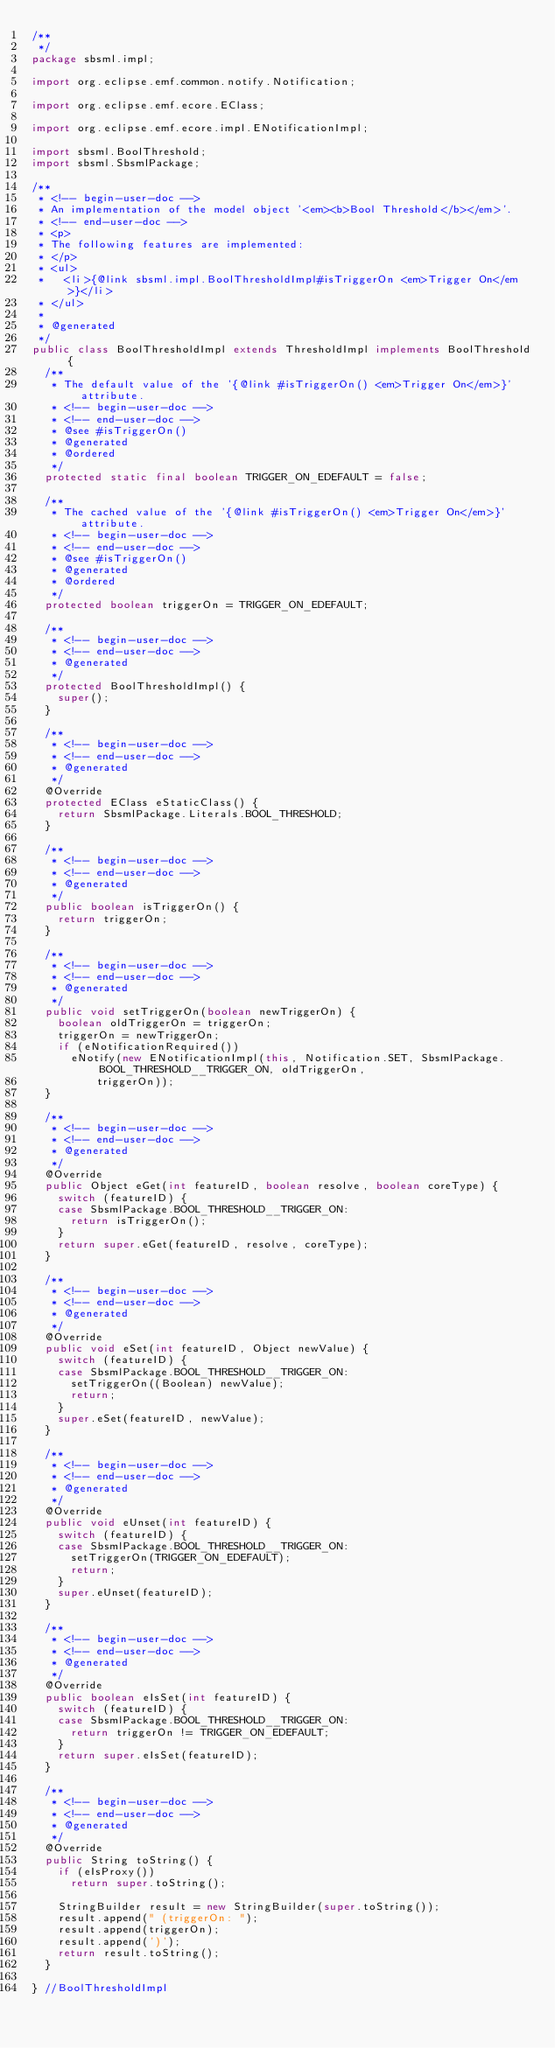Convert code to text. <code><loc_0><loc_0><loc_500><loc_500><_Java_>/**
 */
package sbsml.impl;

import org.eclipse.emf.common.notify.Notification;

import org.eclipse.emf.ecore.EClass;

import org.eclipse.emf.ecore.impl.ENotificationImpl;

import sbsml.BoolThreshold;
import sbsml.SbsmlPackage;

/**
 * <!-- begin-user-doc -->
 * An implementation of the model object '<em><b>Bool Threshold</b></em>'.
 * <!-- end-user-doc -->
 * <p>
 * The following features are implemented:
 * </p>
 * <ul>
 *   <li>{@link sbsml.impl.BoolThresholdImpl#isTriggerOn <em>Trigger On</em>}</li>
 * </ul>
 *
 * @generated
 */
public class BoolThresholdImpl extends ThresholdImpl implements BoolThreshold {
	/**
	 * The default value of the '{@link #isTriggerOn() <em>Trigger On</em>}' attribute.
	 * <!-- begin-user-doc -->
	 * <!-- end-user-doc -->
	 * @see #isTriggerOn()
	 * @generated
	 * @ordered
	 */
	protected static final boolean TRIGGER_ON_EDEFAULT = false;

	/**
	 * The cached value of the '{@link #isTriggerOn() <em>Trigger On</em>}' attribute.
	 * <!-- begin-user-doc -->
	 * <!-- end-user-doc -->
	 * @see #isTriggerOn()
	 * @generated
	 * @ordered
	 */
	protected boolean triggerOn = TRIGGER_ON_EDEFAULT;

	/**
	 * <!-- begin-user-doc -->
	 * <!-- end-user-doc -->
	 * @generated
	 */
	protected BoolThresholdImpl() {
		super();
	}

	/**
	 * <!-- begin-user-doc -->
	 * <!-- end-user-doc -->
	 * @generated
	 */
	@Override
	protected EClass eStaticClass() {
		return SbsmlPackage.Literals.BOOL_THRESHOLD;
	}

	/**
	 * <!-- begin-user-doc -->
	 * <!-- end-user-doc -->
	 * @generated
	 */
	public boolean isTriggerOn() {
		return triggerOn;
	}

	/**
	 * <!-- begin-user-doc -->
	 * <!-- end-user-doc -->
	 * @generated
	 */
	public void setTriggerOn(boolean newTriggerOn) {
		boolean oldTriggerOn = triggerOn;
		triggerOn = newTriggerOn;
		if (eNotificationRequired())
			eNotify(new ENotificationImpl(this, Notification.SET, SbsmlPackage.BOOL_THRESHOLD__TRIGGER_ON, oldTriggerOn,
					triggerOn));
	}

	/**
	 * <!-- begin-user-doc -->
	 * <!-- end-user-doc -->
	 * @generated
	 */
	@Override
	public Object eGet(int featureID, boolean resolve, boolean coreType) {
		switch (featureID) {
		case SbsmlPackage.BOOL_THRESHOLD__TRIGGER_ON:
			return isTriggerOn();
		}
		return super.eGet(featureID, resolve, coreType);
	}

	/**
	 * <!-- begin-user-doc -->
	 * <!-- end-user-doc -->
	 * @generated
	 */
	@Override
	public void eSet(int featureID, Object newValue) {
		switch (featureID) {
		case SbsmlPackage.BOOL_THRESHOLD__TRIGGER_ON:
			setTriggerOn((Boolean) newValue);
			return;
		}
		super.eSet(featureID, newValue);
	}

	/**
	 * <!-- begin-user-doc -->
	 * <!-- end-user-doc -->
	 * @generated
	 */
	@Override
	public void eUnset(int featureID) {
		switch (featureID) {
		case SbsmlPackage.BOOL_THRESHOLD__TRIGGER_ON:
			setTriggerOn(TRIGGER_ON_EDEFAULT);
			return;
		}
		super.eUnset(featureID);
	}

	/**
	 * <!-- begin-user-doc -->
	 * <!-- end-user-doc -->
	 * @generated
	 */
	@Override
	public boolean eIsSet(int featureID) {
		switch (featureID) {
		case SbsmlPackage.BOOL_THRESHOLD__TRIGGER_ON:
			return triggerOn != TRIGGER_ON_EDEFAULT;
		}
		return super.eIsSet(featureID);
	}

	/**
	 * <!-- begin-user-doc -->
	 * <!-- end-user-doc -->
	 * @generated
	 */
	@Override
	public String toString() {
		if (eIsProxy())
			return super.toString();

		StringBuilder result = new StringBuilder(super.toString());
		result.append(" (triggerOn: ");
		result.append(triggerOn);
		result.append(')');
		return result.toString();
	}

} //BoolThresholdImpl
</code> 